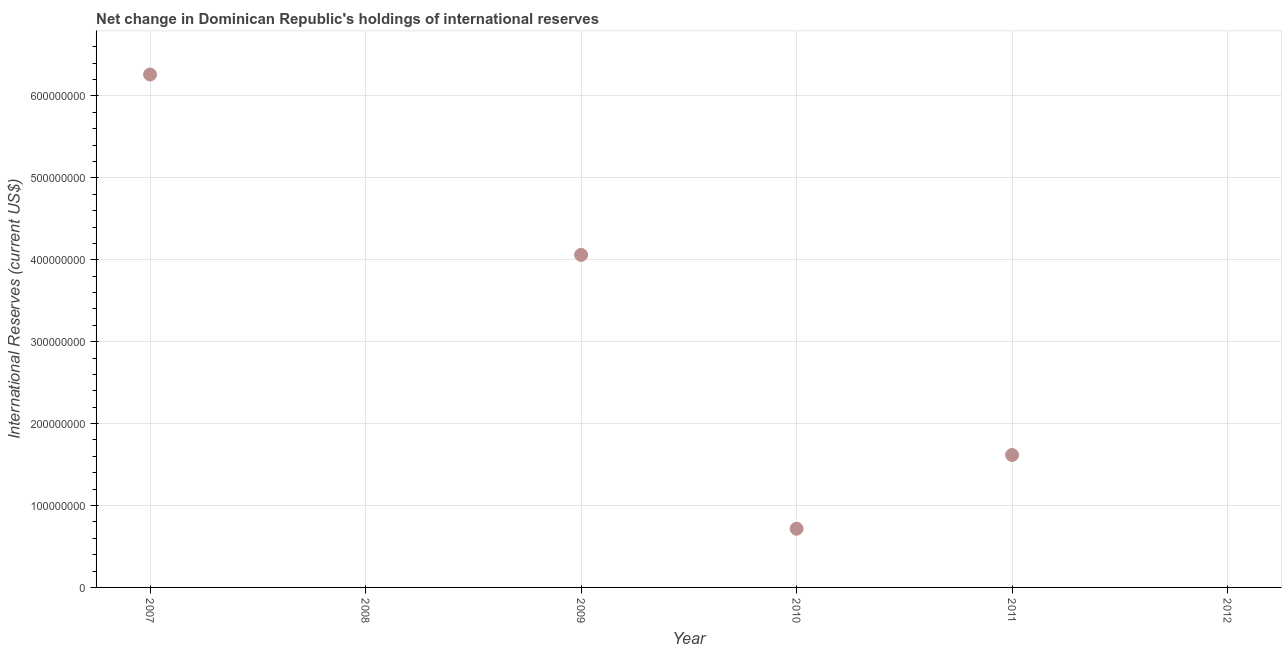What is the reserves and related items in 2007?
Your answer should be very brief. 6.26e+08. Across all years, what is the maximum reserves and related items?
Your answer should be very brief. 6.26e+08. Across all years, what is the minimum reserves and related items?
Give a very brief answer. 0. In which year was the reserves and related items maximum?
Offer a terse response. 2007. What is the sum of the reserves and related items?
Give a very brief answer. 1.27e+09. What is the difference between the reserves and related items in 2007 and 2009?
Offer a very short reply. 2.20e+08. What is the average reserves and related items per year?
Keep it short and to the point. 2.11e+08. What is the median reserves and related items?
Your response must be concise. 1.17e+08. In how many years, is the reserves and related items greater than 280000000 US$?
Give a very brief answer. 2. Is the difference between the reserves and related items in 2010 and 2011 greater than the difference between any two years?
Offer a very short reply. No. What is the difference between the highest and the second highest reserves and related items?
Provide a succinct answer. 2.20e+08. What is the difference between the highest and the lowest reserves and related items?
Ensure brevity in your answer.  6.26e+08. Does the reserves and related items monotonically increase over the years?
Give a very brief answer. No. How many years are there in the graph?
Provide a succinct answer. 6. What is the difference between two consecutive major ticks on the Y-axis?
Your answer should be compact. 1.00e+08. Are the values on the major ticks of Y-axis written in scientific E-notation?
Make the answer very short. No. What is the title of the graph?
Make the answer very short. Net change in Dominican Republic's holdings of international reserves. What is the label or title of the X-axis?
Provide a succinct answer. Year. What is the label or title of the Y-axis?
Ensure brevity in your answer.  International Reserves (current US$). What is the International Reserves (current US$) in 2007?
Give a very brief answer. 6.26e+08. What is the International Reserves (current US$) in 2009?
Your answer should be compact. 4.06e+08. What is the International Reserves (current US$) in 2010?
Your answer should be very brief. 7.17e+07. What is the International Reserves (current US$) in 2011?
Ensure brevity in your answer.  1.62e+08. What is the difference between the International Reserves (current US$) in 2007 and 2009?
Make the answer very short. 2.20e+08. What is the difference between the International Reserves (current US$) in 2007 and 2010?
Your answer should be compact. 5.55e+08. What is the difference between the International Reserves (current US$) in 2007 and 2011?
Your answer should be compact. 4.65e+08. What is the difference between the International Reserves (current US$) in 2009 and 2010?
Your response must be concise. 3.34e+08. What is the difference between the International Reserves (current US$) in 2009 and 2011?
Your answer should be very brief. 2.44e+08. What is the difference between the International Reserves (current US$) in 2010 and 2011?
Provide a short and direct response. -9.00e+07. What is the ratio of the International Reserves (current US$) in 2007 to that in 2009?
Offer a terse response. 1.54. What is the ratio of the International Reserves (current US$) in 2007 to that in 2010?
Offer a very short reply. 8.74. What is the ratio of the International Reserves (current US$) in 2007 to that in 2011?
Provide a succinct answer. 3.87. What is the ratio of the International Reserves (current US$) in 2009 to that in 2010?
Ensure brevity in your answer.  5.67. What is the ratio of the International Reserves (current US$) in 2009 to that in 2011?
Ensure brevity in your answer.  2.51. What is the ratio of the International Reserves (current US$) in 2010 to that in 2011?
Make the answer very short. 0.44. 